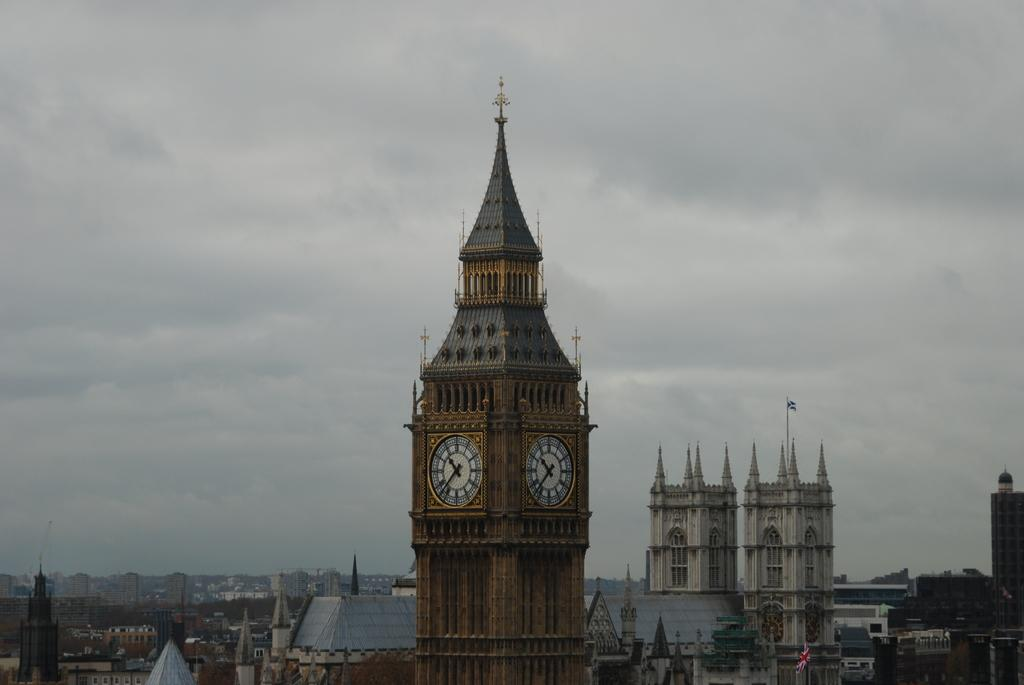What type of structures can be seen in the image? There are buildings in the image. What other natural elements are present in the image? There are trees in the image. What is visible in the background of the image? The sky is visible in the image. What can be observed in the sky? Clouds are present in the sky. What type of silk is draped over the furniture in the image? There is no furniture or silk present in the image. 